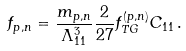<formula> <loc_0><loc_0><loc_500><loc_500>f _ { p , n } = \frac { m _ { p , n } } { \Lambda _ { 1 1 } ^ { 3 } } \frac { 2 } { 2 7 } f ^ { ( p , n ) } _ { T G } C _ { 1 1 } \, .</formula> 